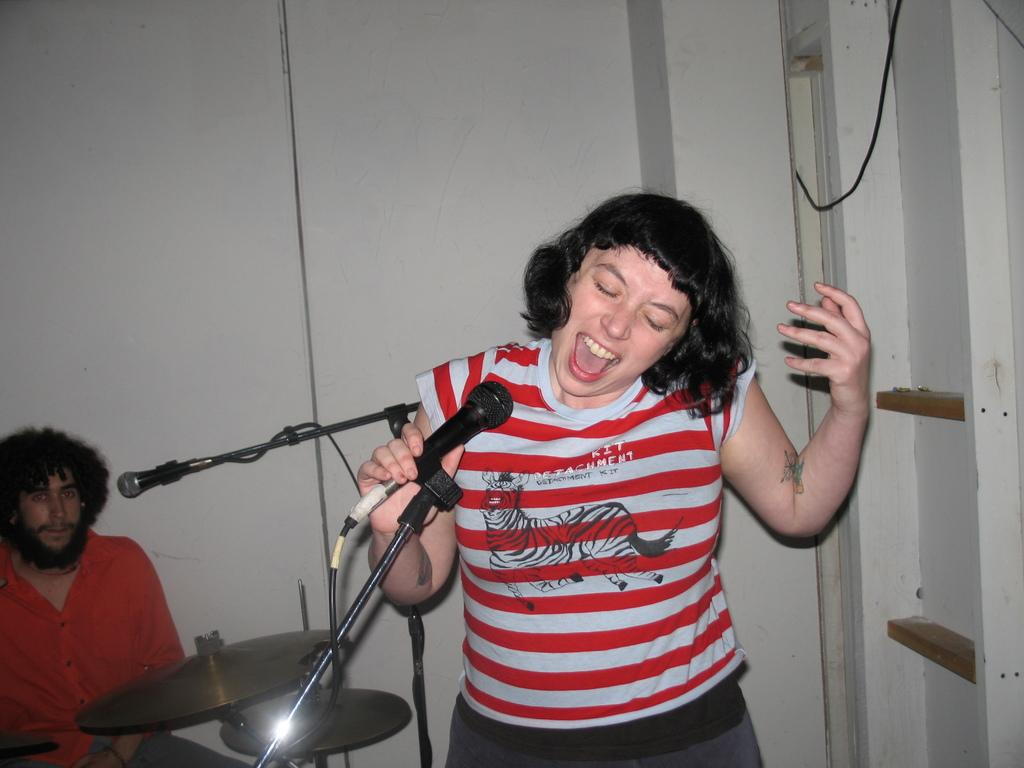What is the main subject of the image? There is a person standing in the image. What object is present near the person? There is a microphone in the image. What is the man in the image doing? The man is sitting and playing a drum set. What type of celery can be seen growing in the image? There is no celery present in the image; it features a person standing, a microphone, and a man playing a drum set. 